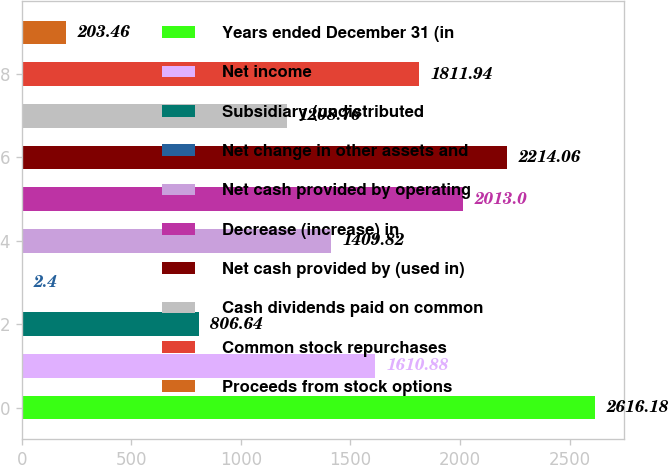Convert chart to OTSL. <chart><loc_0><loc_0><loc_500><loc_500><bar_chart><fcel>Years ended December 31 (in<fcel>Net income<fcel>Subsidiary (undistributed<fcel>Net change in other assets and<fcel>Net cash provided by operating<fcel>Decrease (increase) in<fcel>Net cash provided by (used in)<fcel>Cash dividends paid on common<fcel>Common stock repurchases<fcel>Proceeds from stock options<nl><fcel>2616.18<fcel>1610.88<fcel>806.64<fcel>2.4<fcel>1409.82<fcel>2013<fcel>2214.06<fcel>1208.76<fcel>1811.94<fcel>203.46<nl></chart> 